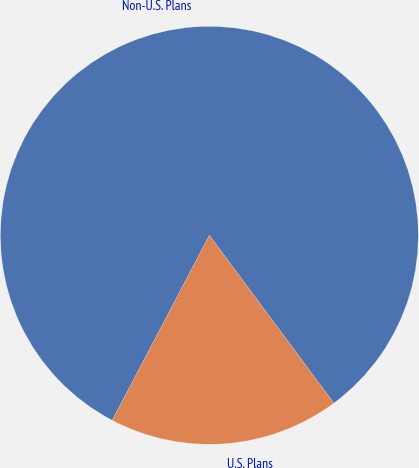Convert chart to OTSL. <chart><loc_0><loc_0><loc_500><loc_500><pie_chart><fcel>Non-U.S. Plans<fcel>U.S. Plans<nl><fcel>82.15%<fcel>17.85%<nl></chart> 